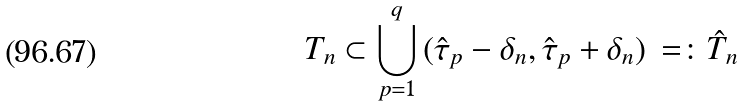Convert formula to latex. <formula><loc_0><loc_0><loc_500><loc_500>T _ { n } \subset \bigcup _ { p = 1 } ^ { q } \, ( \hat { \tau } _ { p } - \delta _ { n } , \hat { \tau } _ { p } + \delta _ { n } ) \, = \colon \hat { T } _ { n }</formula> 